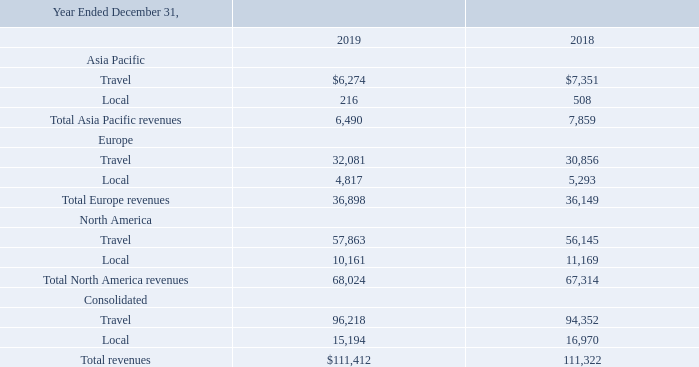The following table sets forth the breakdown of revenues by category and segment. Travel revenue includes travel publications (Top 20, Website, Newsflash, Travelzoo Network), Getaway vouchers and hotel platform. Local revenue includes Local Deals vouchers and entertainment offers (vouchers and direct bookings) (in thousands).
Revenue by geography is based on the billing address of the advertiser. Long-lived assets attributed to the U.S. and international geographies are based upon the country in which the asset is located or owned.
What is revenue by geography based on? Billing address of the advertiser. What is the total Asia Pacific revenues in 2019 and 2018 respectively?
Answer scale should be: thousand. 6,490, 7,859. What is the total Europe revenues in 2019 and 2018 respectively?
Answer scale should be: thousand. 36,898, 36,149. What is the change in total revenues between 2018 and 2019?
Answer scale should be: thousand. 111,412-111,322
Answer: 90. What is the average of the total Asia Pacific revenues in 2018 and 2019?
Answer scale should be: thousand. (6,490+ 7,859)/2
Answer: 7174.5. In 2019, how many geographic regions have total revenues of more than $20,000 thousand? Europe ## North America
Answer: 2. 